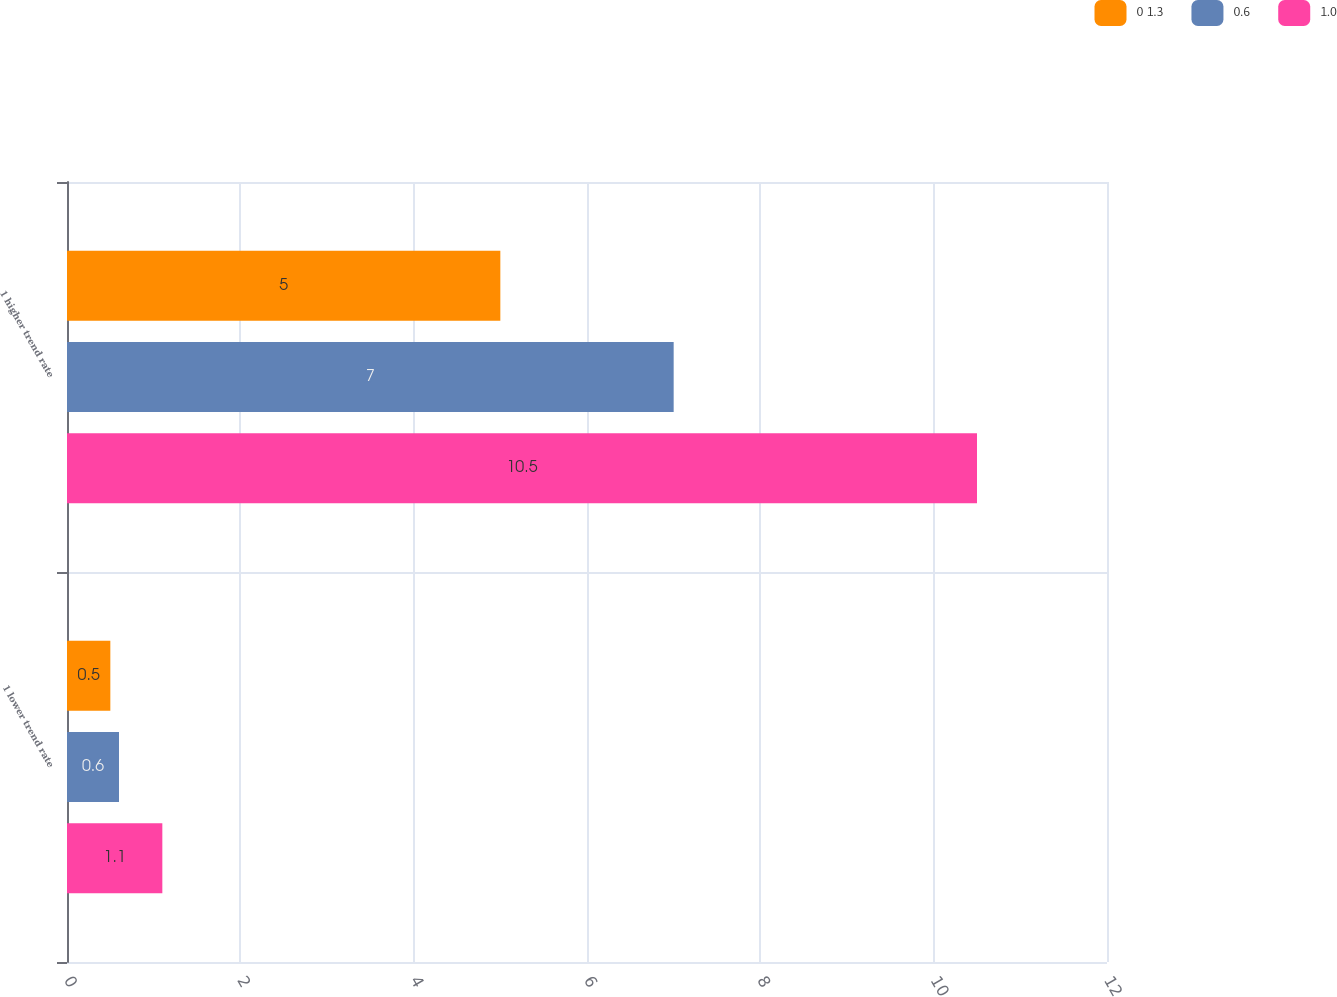Convert chart to OTSL. <chart><loc_0><loc_0><loc_500><loc_500><stacked_bar_chart><ecel><fcel>1 lower trend rate<fcel>1 higher trend rate<nl><fcel>0 1.3<fcel>0.5<fcel>5<nl><fcel>0.6<fcel>0.6<fcel>7<nl><fcel>1.0<fcel>1.1<fcel>10.5<nl></chart> 